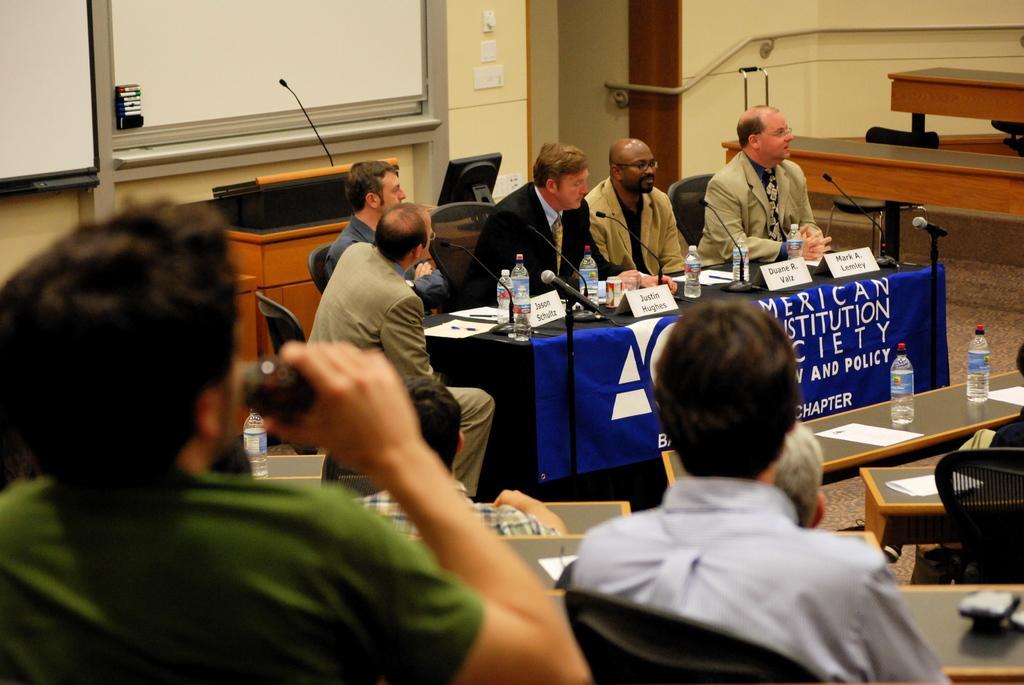Please provide a concise description of this image. There are groups of people sitting on the chairs. This is a table covered with a cloth. I can see the name boards, mike's, water bottles, papers and few other things on it. These are the mics attached to the mike stands. This looks like a podium with a mike. I think this is a whiteboard. These look like the marker pens. These are the tables and chairs. Here is another table with water bottles and papers on it. 